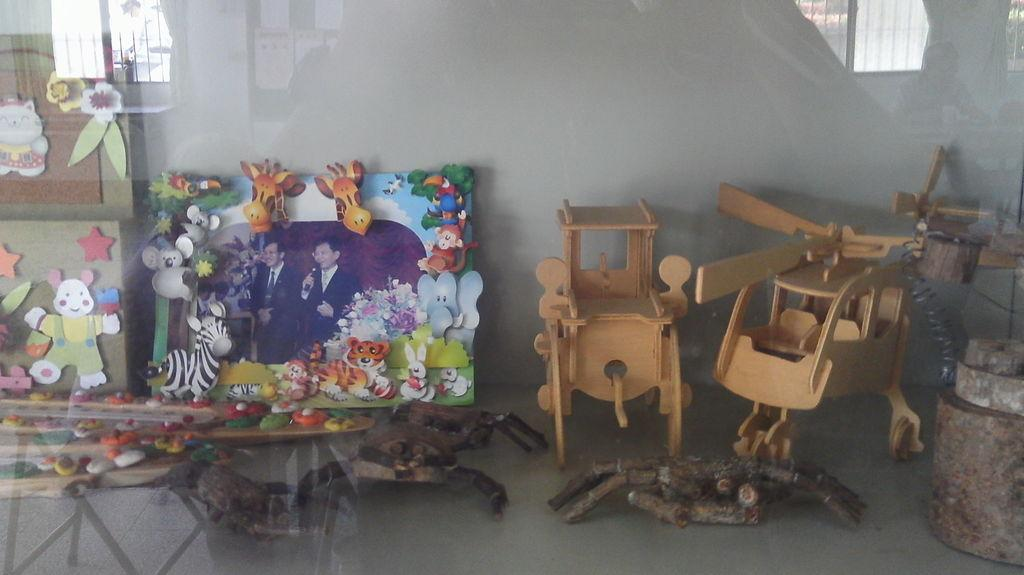What type of objects are made of wood in the image? There are two wooden objects in the image. What type of artwork is present in the image? There are two paintings in the image. What part of the room can be seen in the image? The floor is visible in the image. Where are the dinosaurs located in the image? There are no dinosaurs present in the image. How many sons are visible in the image? There is no reference to a son or any people in the image. 